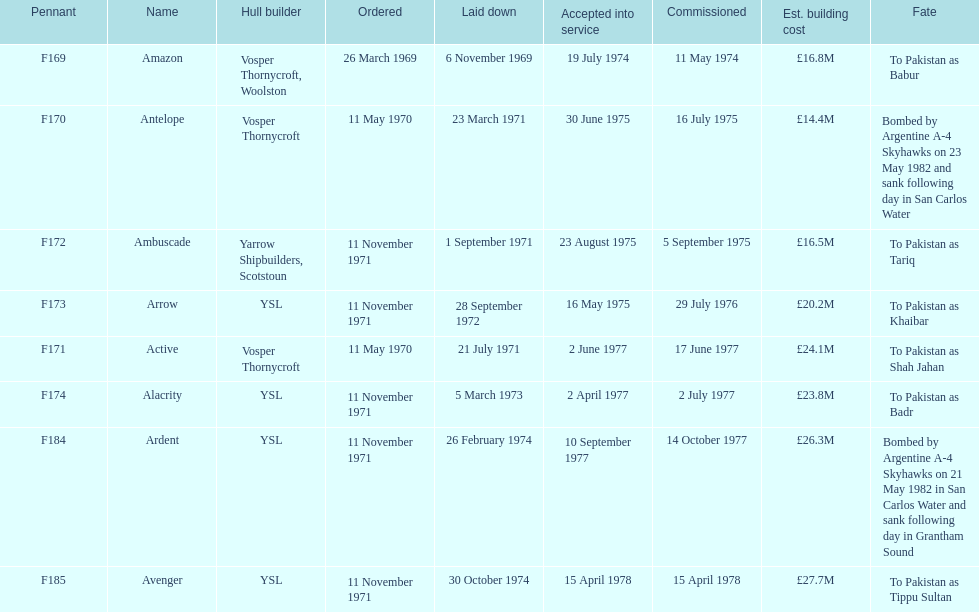During september, how many ships were set for construction? 2. 